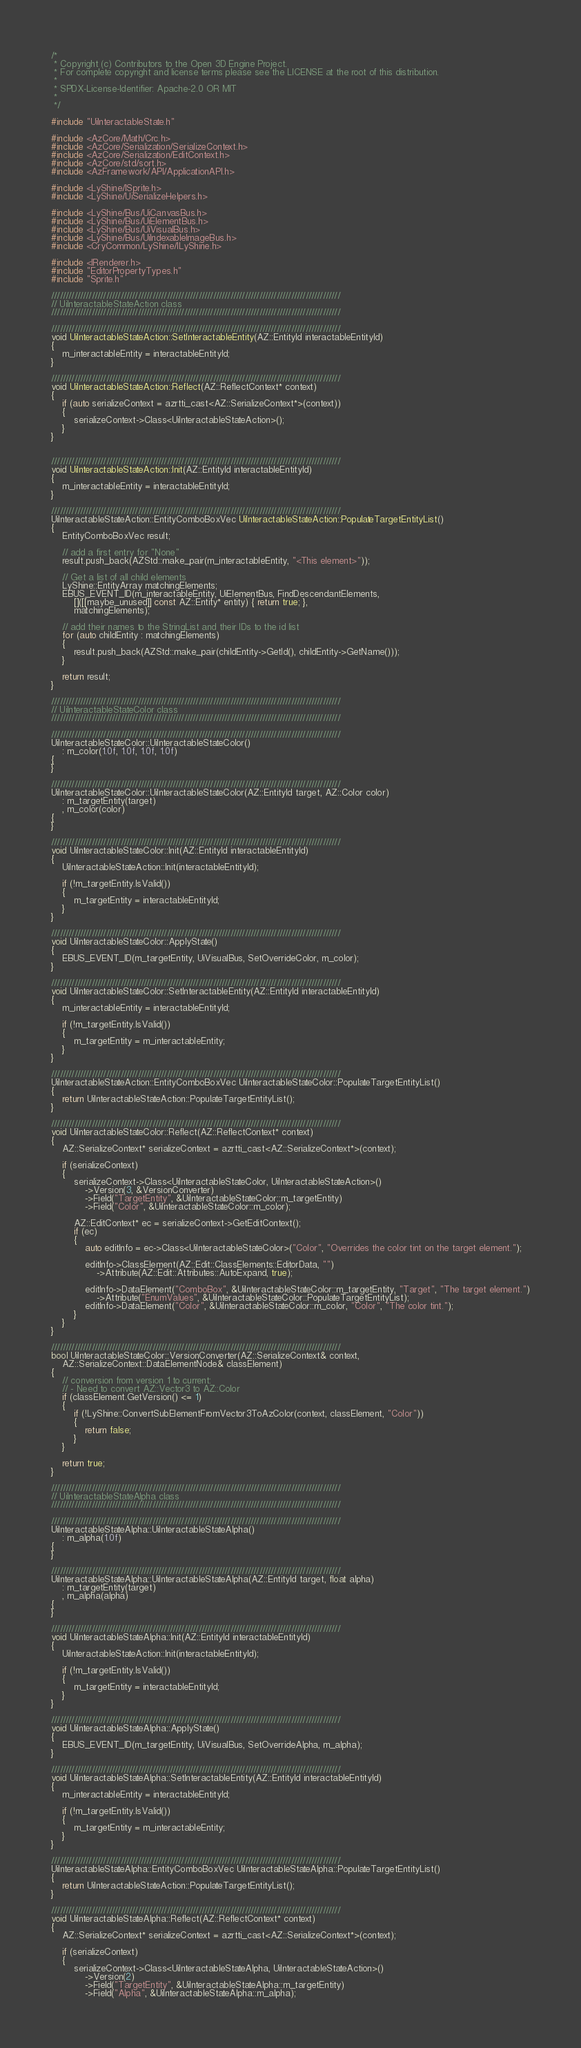Convert code to text. <code><loc_0><loc_0><loc_500><loc_500><_C++_>/*
 * Copyright (c) Contributors to the Open 3D Engine Project.
 * For complete copyright and license terms please see the LICENSE at the root of this distribution.
 *
 * SPDX-License-Identifier: Apache-2.0 OR MIT
 *
 */

#include "UiInteractableState.h"

#include <AzCore/Math/Crc.h>
#include <AzCore/Serialization/SerializeContext.h>
#include <AzCore/Serialization/EditContext.h>
#include <AzCore/std/sort.h>
#include <AzFramework/API/ApplicationAPI.h>

#include <LyShine/ISprite.h>
#include <LyShine/UiSerializeHelpers.h>

#include <LyShine/Bus/UiCanvasBus.h>
#include <LyShine/Bus/UiElementBus.h>
#include <LyShine/Bus/UiVisualBus.h>
#include <LyShine/Bus/UiIndexableImageBus.h>
#include <CryCommon/LyShine/ILyShine.h>

#include <IRenderer.h>
#include "EditorPropertyTypes.h"
#include "Sprite.h"

////////////////////////////////////////////////////////////////////////////////////////////////////
// UiInteractableStateAction class
////////////////////////////////////////////////////////////////////////////////////////////////////

////////////////////////////////////////////////////////////////////////////////////////////////////
void UiInteractableStateAction::SetInteractableEntity(AZ::EntityId interactableEntityId)
{
    m_interactableEntity = interactableEntityId;
}

////////////////////////////////////////////////////////////////////////////////////////////////////
void UiInteractableStateAction::Reflect(AZ::ReflectContext* context)
{
    if (auto serializeContext = azrtti_cast<AZ::SerializeContext*>(context))
    {
        serializeContext->Class<UiInteractableStateAction>();
    }
}


////////////////////////////////////////////////////////////////////////////////////////////////////
void UiInteractableStateAction::Init(AZ::EntityId interactableEntityId)
{
    m_interactableEntity = interactableEntityId;
}

////////////////////////////////////////////////////////////////////////////////////////////////////
UiInteractableStateAction::EntityComboBoxVec UiInteractableStateAction::PopulateTargetEntityList()
{
    EntityComboBoxVec result;

    // add a first entry for "None"
    result.push_back(AZStd::make_pair(m_interactableEntity, "<This element>"));

    // Get a list of all child elements
    LyShine::EntityArray matchingElements;
    EBUS_EVENT_ID(m_interactableEntity, UiElementBus, FindDescendantElements,
        []([[maybe_unused]] const AZ::Entity* entity) { return true; },
        matchingElements);

    // add their names to the StringList and their IDs to the id list
    for (auto childEntity : matchingElements)
    {
        result.push_back(AZStd::make_pair(childEntity->GetId(), childEntity->GetName()));
    }

    return result;
}

////////////////////////////////////////////////////////////////////////////////////////////////////
// UiInteractableStateColor class
////////////////////////////////////////////////////////////////////////////////////////////////////

////////////////////////////////////////////////////////////////////////////////////////////////////
UiInteractableStateColor::UiInteractableStateColor()
    : m_color(1.0f, 1.0f, 1.0f, 1.0f)
{
}

////////////////////////////////////////////////////////////////////////////////////////////////////
UiInteractableStateColor::UiInteractableStateColor(AZ::EntityId target, AZ::Color color)
    : m_targetEntity(target)
    , m_color(color)
{
}

////////////////////////////////////////////////////////////////////////////////////////////////////
void UiInteractableStateColor::Init(AZ::EntityId interactableEntityId)
{
    UiInteractableStateAction::Init(interactableEntityId);

    if (!m_targetEntity.IsValid())
    {
        m_targetEntity = interactableEntityId;
    }
}

////////////////////////////////////////////////////////////////////////////////////////////////////
void UiInteractableStateColor::ApplyState()
{
    EBUS_EVENT_ID(m_targetEntity, UiVisualBus, SetOverrideColor, m_color);
}

////////////////////////////////////////////////////////////////////////////////////////////////////
void UiInteractableStateColor::SetInteractableEntity(AZ::EntityId interactableEntityId)
{
    m_interactableEntity = interactableEntityId;

    if (!m_targetEntity.IsValid())
    {
        m_targetEntity = m_interactableEntity;
    }
}

////////////////////////////////////////////////////////////////////////////////////////////////////
UiInteractableStateAction::EntityComboBoxVec UiInteractableStateColor::PopulateTargetEntityList()
{
    return UiInteractableStateAction::PopulateTargetEntityList();
}

////////////////////////////////////////////////////////////////////////////////////////////////////
void UiInteractableStateColor::Reflect(AZ::ReflectContext* context)
{
    AZ::SerializeContext* serializeContext = azrtti_cast<AZ::SerializeContext*>(context);

    if (serializeContext)
    {
        serializeContext->Class<UiInteractableStateColor, UiInteractableStateAction>()
            ->Version(3, &VersionConverter)
            ->Field("TargetEntity", &UiInteractableStateColor::m_targetEntity)
            ->Field("Color", &UiInteractableStateColor::m_color);

        AZ::EditContext* ec = serializeContext->GetEditContext();
        if (ec)
        {
            auto editInfo = ec->Class<UiInteractableStateColor>("Color", "Overrides the color tint on the target element.");

            editInfo->ClassElement(AZ::Edit::ClassElements::EditorData, "")
                ->Attribute(AZ::Edit::Attributes::AutoExpand, true);

            editInfo->DataElement("ComboBox", &UiInteractableStateColor::m_targetEntity, "Target", "The target element.")
                ->Attribute("EnumValues", &UiInteractableStateColor::PopulateTargetEntityList);
            editInfo->DataElement("Color", &UiInteractableStateColor::m_color, "Color", "The color tint.");
        }
    }
}

////////////////////////////////////////////////////////////////////////////////////////////////////
bool UiInteractableStateColor::VersionConverter(AZ::SerializeContext& context,
    AZ::SerializeContext::DataElementNode& classElement)
{
    // conversion from version 1 to current:
    // - Need to convert AZ::Vector3 to AZ::Color
    if (classElement.GetVersion() <= 1)
    {
        if (!LyShine::ConvertSubElementFromVector3ToAzColor(context, classElement, "Color"))
        {
            return false;
        }
    }

    return true;
}

////////////////////////////////////////////////////////////////////////////////////////////////////
// UiInteractableStateAlpha class
////////////////////////////////////////////////////////////////////////////////////////////////////

////////////////////////////////////////////////////////////////////////////////////////////////////
UiInteractableStateAlpha::UiInteractableStateAlpha()
    : m_alpha(1.0f)
{
}

////////////////////////////////////////////////////////////////////////////////////////////////////
UiInteractableStateAlpha::UiInteractableStateAlpha(AZ::EntityId target, float alpha)
    : m_targetEntity(target)
    , m_alpha(alpha)
{
}

////////////////////////////////////////////////////////////////////////////////////////////////////
void UiInteractableStateAlpha::Init(AZ::EntityId interactableEntityId)
{
    UiInteractableStateAction::Init(interactableEntityId);

    if (!m_targetEntity.IsValid())
    {
        m_targetEntity = interactableEntityId;
    }
}

////////////////////////////////////////////////////////////////////////////////////////////////////
void UiInteractableStateAlpha::ApplyState()
{
    EBUS_EVENT_ID(m_targetEntity, UiVisualBus, SetOverrideAlpha, m_alpha);
}

////////////////////////////////////////////////////////////////////////////////////////////////////
void UiInteractableStateAlpha::SetInteractableEntity(AZ::EntityId interactableEntityId)
{
    m_interactableEntity = interactableEntityId;

    if (!m_targetEntity.IsValid())
    {
        m_targetEntity = m_interactableEntity;
    }
}

////////////////////////////////////////////////////////////////////////////////////////////////////
UiInteractableStateAlpha::EntityComboBoxVec UiInteractableStateAlpha::PopulateTargetEntityList()
{
    return UiInteractableStateAction::PopulateTargetEntityList();
}

////////////////////////////////////////////////////////////////////////////////////////////////////
void UiInteractableStateAlpha::Reflect(AZ::ReflectContext* context)
{
    AZ::SerializeContext* serializeContext = azrtti_cast<AZ::SerializeContext*>(context);

    if (serializeContext)
    {
        serializeContext->Class<UiInteractableStateAlpha, UiInteractableStateAction>()
            ->Version(2)
            ->Field("TargetEntity", &UiInteractableStateAlpha::m_targetEntity)
            ->Field("Alpha", &UiInteractableStateAlpha::m_alpha);
</code> 